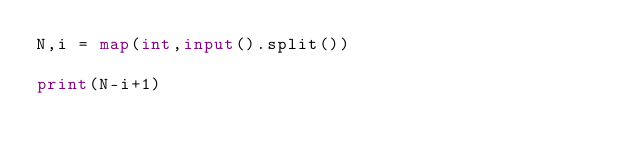Convert code to text. <code><loc_0><loc_0><loc_500><loc_500><_Python_>N,i = map(int,input().split())

print(N-i+1)</code> 